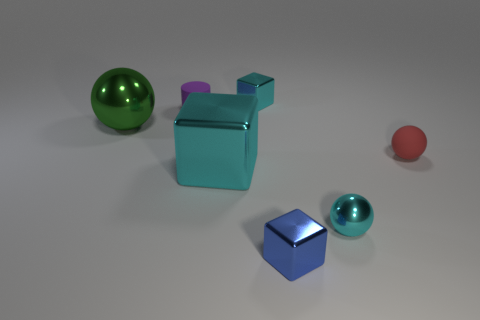Add 2 green balls. How many objects exist? 9 Subtract all cylinders. How many objects are left? 6 Add 2 large cyan shiny objects. How many large cyan shiny objects exist? 3 Subtract 0 purple cubes. How many objects are left? 7 Subtract all big purple rubber cubes. Subtract all large cubes. How many objects are left? 6 Add 3 red balls. How many red balls are left? 4 